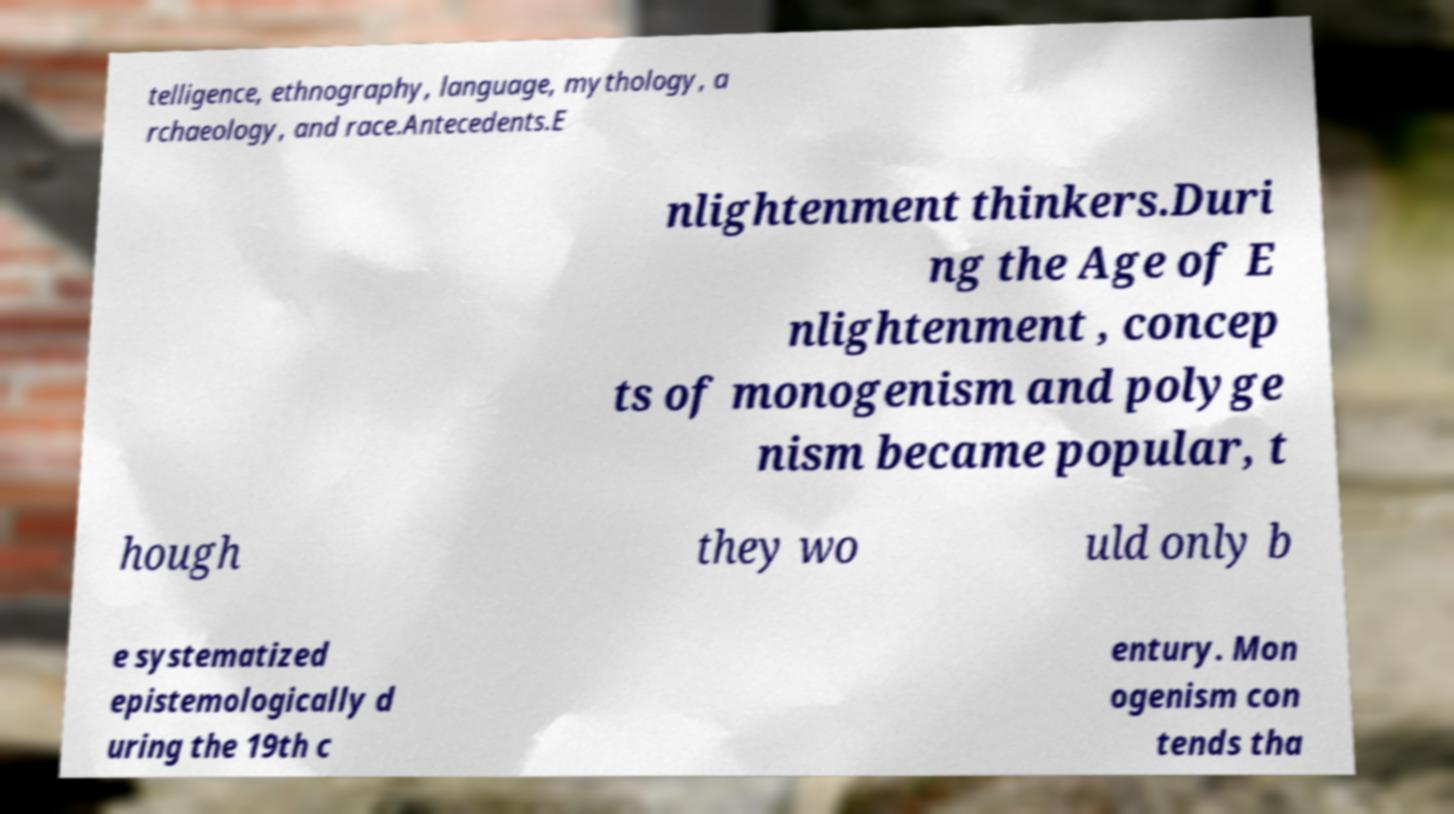Could you extract and type out the text from this image? telligence, ethnography, language, mythology, a rchaeology, and race.Antecedents.E nlightenment thinkers.Duri ng the Age of E nlightenment , concep ts of monogenism and polyge nism became popular, t hough they wo uld only b e systematized epistemologically d uring the 19th c entury. Mon ogenism con tends tha 